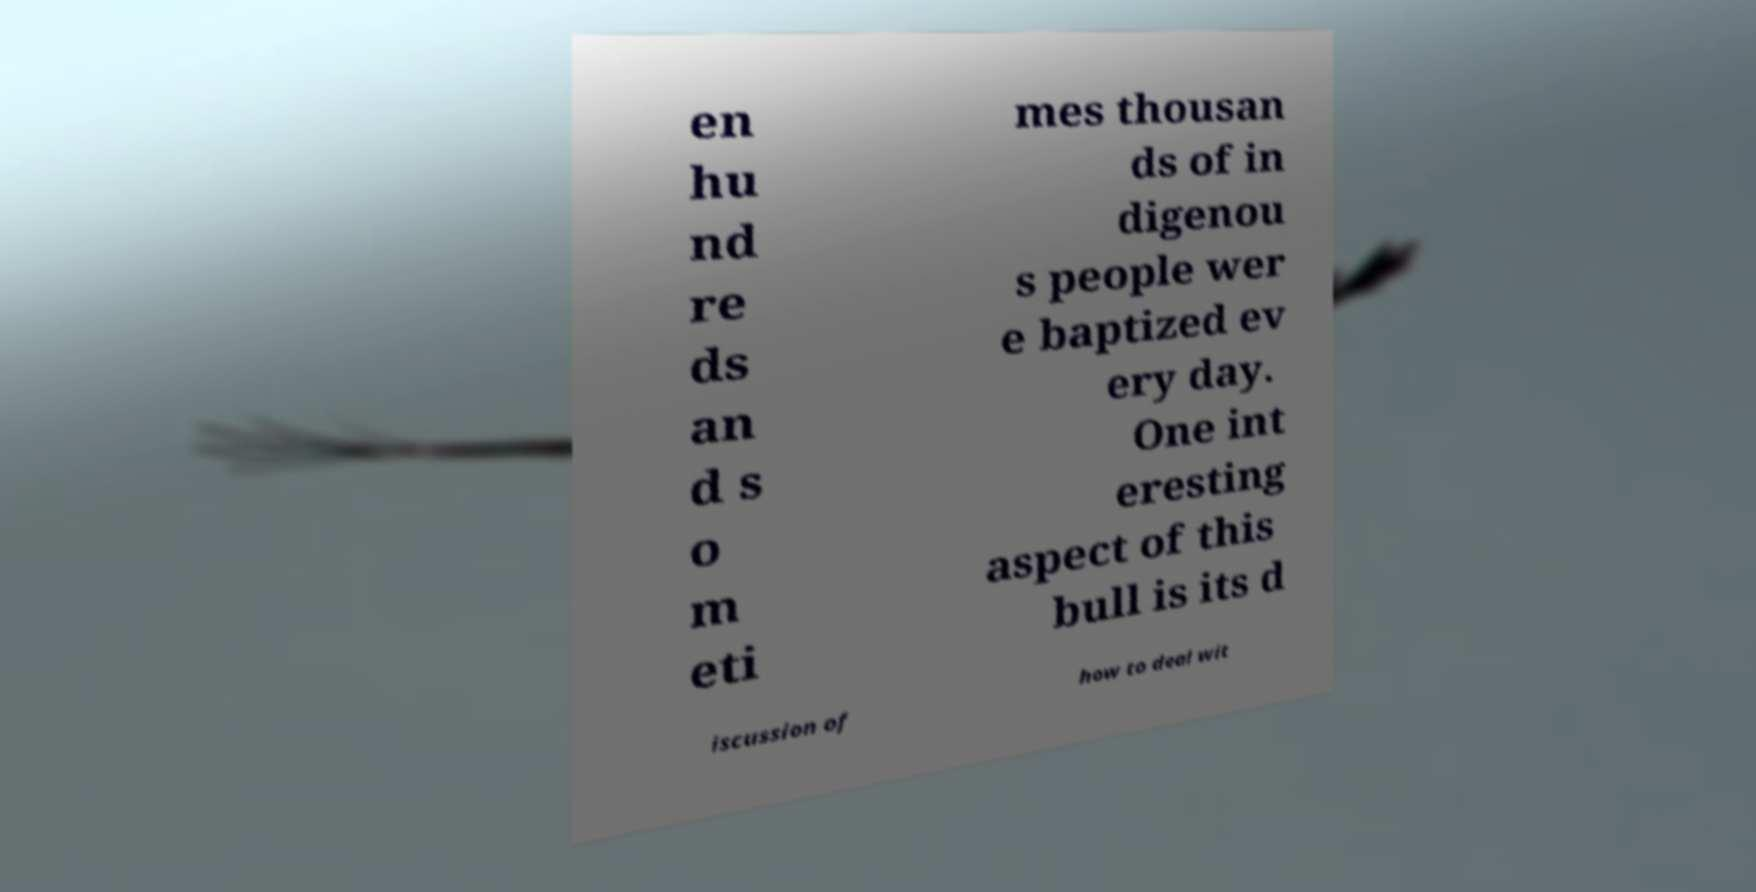Please identify and transcribe the text found in this image. en hu nd re ds an d s o m eti mes thousan ds of in digenou s people wer e baptized ev ery day. One int eresting aspect of this bull is its d iscussion of how to deal wit 